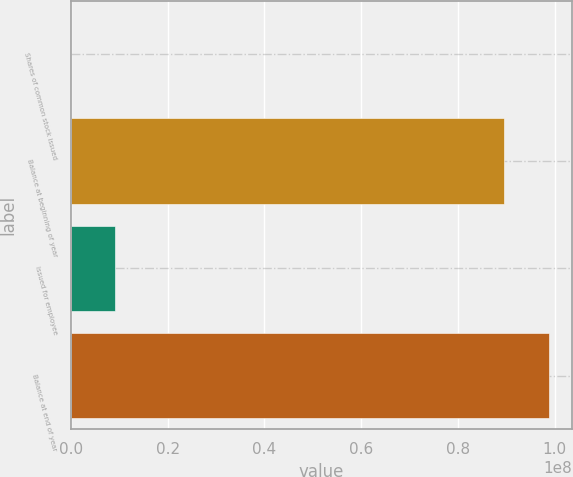Convert chart to OTSL. <chart><loc_0><loc_0><loc_500><loc_500><bar_chart><fcel>Shares of common stock issued<fcel>Balance at beginning of year<fcel>Issued for employee<fcel>Balance at end of year<nl><fcel>2006<fcel>8.95661e+07<fcel>9.15975e+06<fcel>9.87239e+07<nl></chart> 